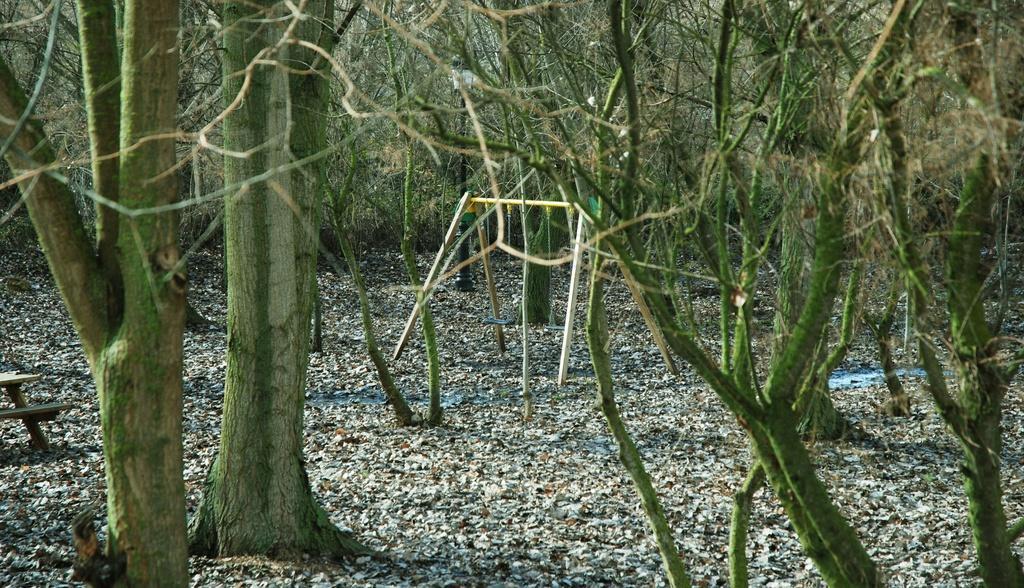Describe this image in one or two sentences. In this image, we can see there is a pole in the middle, and trees are surrounded. 